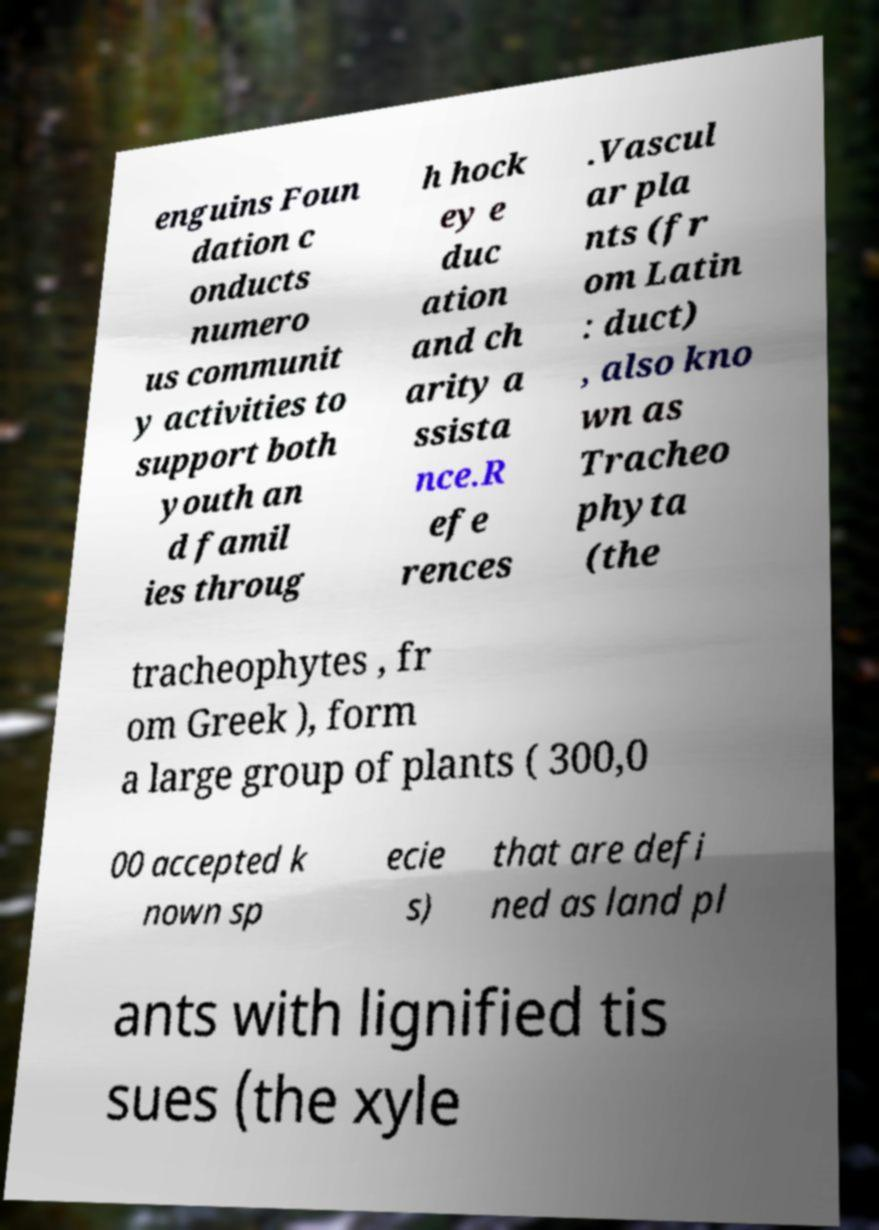Could you extract and type out the text from this image? enguins Foun dation c onducts numero us communit y activities to support both youth an d famil ies throug h hock ey e duc ation and ch arity a ssista nce.R efe rences .Vascul ar pla nts (fr om Latin : duct) , also kno wn as Tracheo phyta (the tracheophytes , fr om Greek ), form a large group of plants ( 300,0 00 accepted k nown sp ecie s) that are defi ned as land pl ants with lignified tis sues (the xyle 